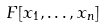Convert formula to latex. <formula><loc_0><loc_0><loc_500><loc_500>F [ x _ { 1 } , \dots , x _ { n } ]</formula> 